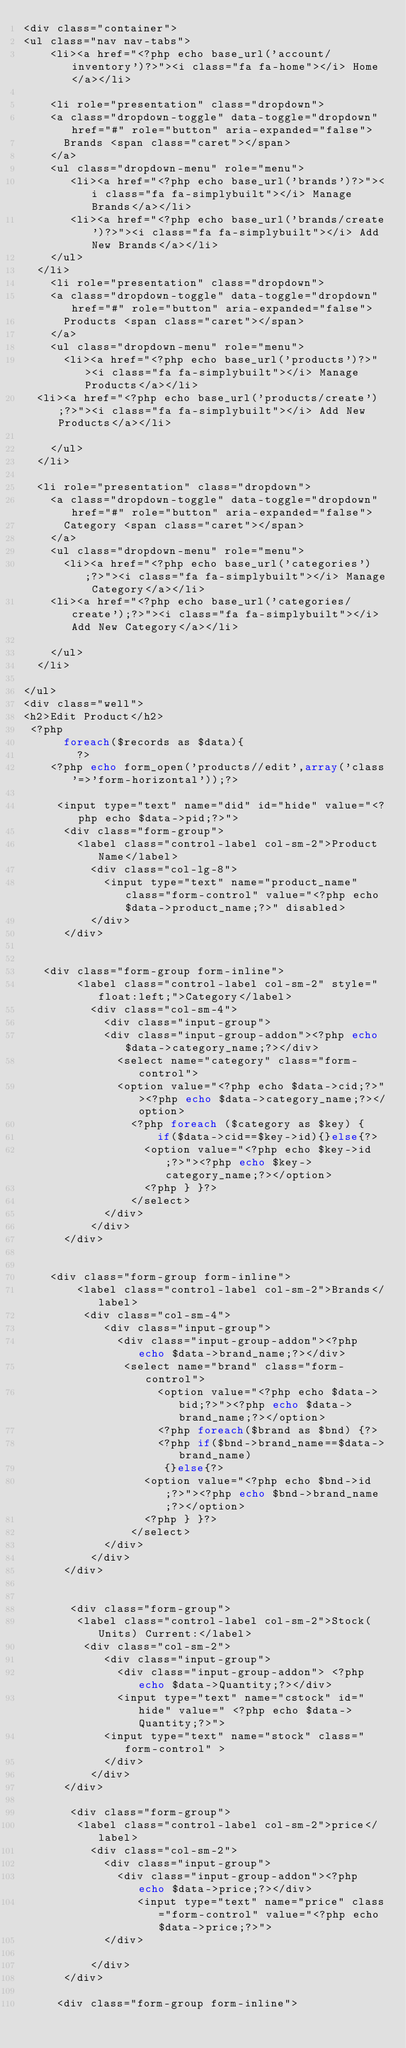Convert code to text. <code><loc_0><loc_0><loc_500><loc_500><_PHP_><div class="container">
<ul class="nav nav-tabs">
 		<li><a href="<?php echo base_url('account/inventory')?>"><i class="fa fa-home"></i> Home</a></li>
       
  	<li role="presentation" class="dropdown">
    <a class="dropdown-toggle" data-toggle="dropdown" href="#" role="button" aria-expanded="false">
      Brands <span class="caret"></span>
    </a>
    <ul class="dropdown-menu" role="menu">
       <li><a href="<?php echo base_url('brands')?>"><i class="fa fa-simplybuilt"></i> Manage Brands</a></li>
       <li><a href="<?php echo base_url('brands/create')?>"><i class="fa fa-simplybuilt"></i> Add New Brands</a></li>
   	</ul>
  </li>
 		<li role="presentation" class="dropdown">
    <a class="dropdown-toggle" data-toggle="dropdown" href="#" role="button" aria-expanded="false">
      Products <span class="caret"></span>
    </a>
    <ul class="dropdown-menu" role="menu">
    	<li><a href="<?php echo base_url('products')?>"><i class="fa fa-simplybuilt"></i> Manage Products</a></li>
	<li><a href="<?php echo base_url('products/create');?>"><i class="fa fa-simplybuilt"></i> Add New Products</a></li>

    </ul>
  </li>

  <li role="presentation" class="dropdown">
    <a class="dropdown-toggle" data-toggle="dropdown" href="#" role="button" aria-expanded="false">
      Category <span class="caret"></span>
    </a>
    <ul class="dropdown-menu" role="menu">
    	<li><a href="<?php echo base_url('categories');?>"><i class="fa fa-simplybuilt"></i> Manage Category</a></li>
		<li><a href="<?php echo base_url('categories/create');?>"><i class="fa fa-simplybuilt"></i> Add New Category</a></li>

    </ul>
  </li>

</ul>
<div class="well"> 
<h2>Edit Product</h2>
 <?php 
      foreach($records as $data){
        ?>
    <?php echo form_open('products//edit',array('class'=>'form-horizontal'));?>
    
     <input type="text" name="did" id="hide" value="<?php echo $data->pid;?>">
      <div class="form-group">
        <label class="control-label col-sm-2">Product Name</label>
          <div class="col-lg-8">
            <input type="text" name="product_name" class="form-control" value="<?php echo $data->product_name;?>" disabled>
          </div>
      </div>


   <div class="form-group form-inline">
        <label class="control-label col-sm-2" style="float:left;">Category</label>
          <div class="col-sm-4">
            <div class="input-group">
            <div class="input-group-addon"><?php echo $data->category_name;?></div>
              <select name="category" class="form-control">
              <option value="<?php echo $data->cid;?>"><?php echo $data->category_name;?></option>
                <?php foreach ($category as $key) {
                    if($data->cid==$key->id){}else{?>
                  <option value="<?php echo $key->id;?>"><?php echo $key->category_name;?></option>
                  <?php } }?>
                </select>
            </div>
          </div>
      </div>


    <div class="form-group form-inline">
        <label class="control-label col-sm-2">Brands</label>
         <div class="col-sm-4">
            <div class="input-group">
              <div class="input-group-addon"><?php echo $data->brand_name;?></div>
               <select name="brand" class="form-control">
                    <option value="<?php echo $data->bid;?>"><?php echo $data->brand_name;?></option>
                    <?php foreach($brand as $bnd) {?>
                    <?php if($bnd->brand_name==$data->brand_name) 
                     {}else{?>
                  <option value="<?php echo $bnd->id;?>"><?php echo $bnd->brand_name;?></option>
                  <?php } }?>
                </select>
            </div>
          </div>
      </div>


       <div class="form-group">
        <label class="control-label col-sm-2">Stock(Units) Current:</label>
         <div class="col-sm-2">
            <div class="input-group">
              <div class="input-group-addon"> <?php echo $data->Quantity;?></div>
              <input type="text" name="cstock" id="hide" value=" <?php echo $data->Quantity;?>">
            <input type="text" name="stock" class="form-control" >
            </div>
          </div>
      </div>

       <div class="form-group">
        <label class="control-label col-sm-2">price</label>
          <div class="col-sm-2">
            <div class="input-group">
              <div class="input-group-addon"><?php echo $data->price;?></div>
                 <input type="text" name="price" class="form-control" value="<?php echo $data->price;?>">
            </div>
           
          </div>
      </div>

     <div class="form-group form-inline"></code> 